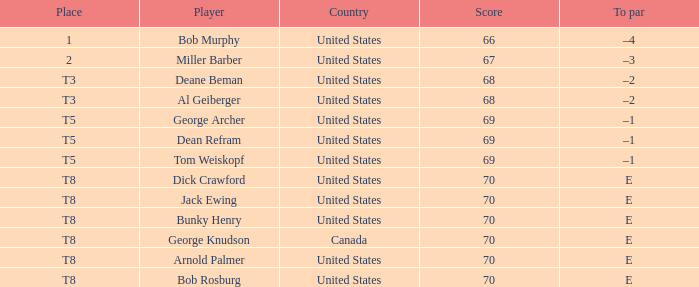When Bunky Henry of the United States scored higher than 68 and his To par was e, what was his place? T8. 